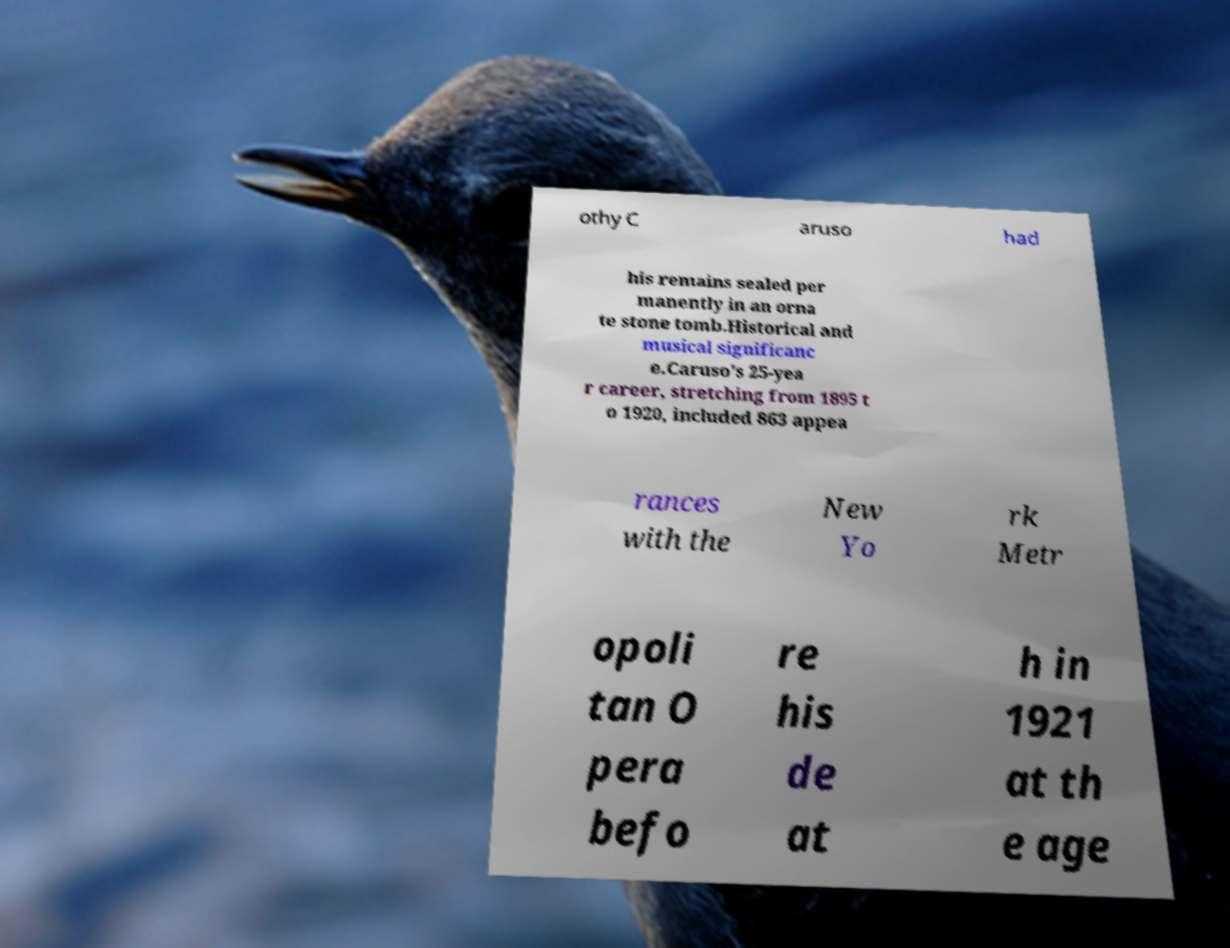For documentation purposes, I need the text within this image transcribed. Could you provide that? othy C aruso had his remains sealed per manently in an orna te stone tomb.Historical and musical significanc e.Caruso's 25-yea r career, stretching from 1895 t o 1920, included 863 appea rances with the New Yo rk Metr opoli tan O pera befo re his de at h in 1921 at th e age 